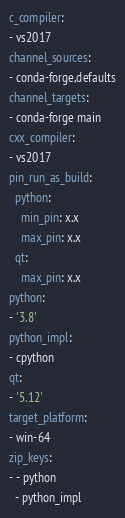<code> <loc_0><loc_0><loc_500><loc_500><_YAML_>c_compiler:
- vs2017
channel_sources:
- conda-forge,defaults
channel_targets:
- conda-forge main
cxx_compiler:
- vs2017
pin_run_as_build:
  python:
    min_pin: x.x
    max_pin: x.x
  qt:
    max_pin: x.x
python:
- '3.8'
python_impl:
- cpython
qt:
- '5.12'
target_platform:
- win-64
zip_keys:
- - python
  - python_impl
</code> 